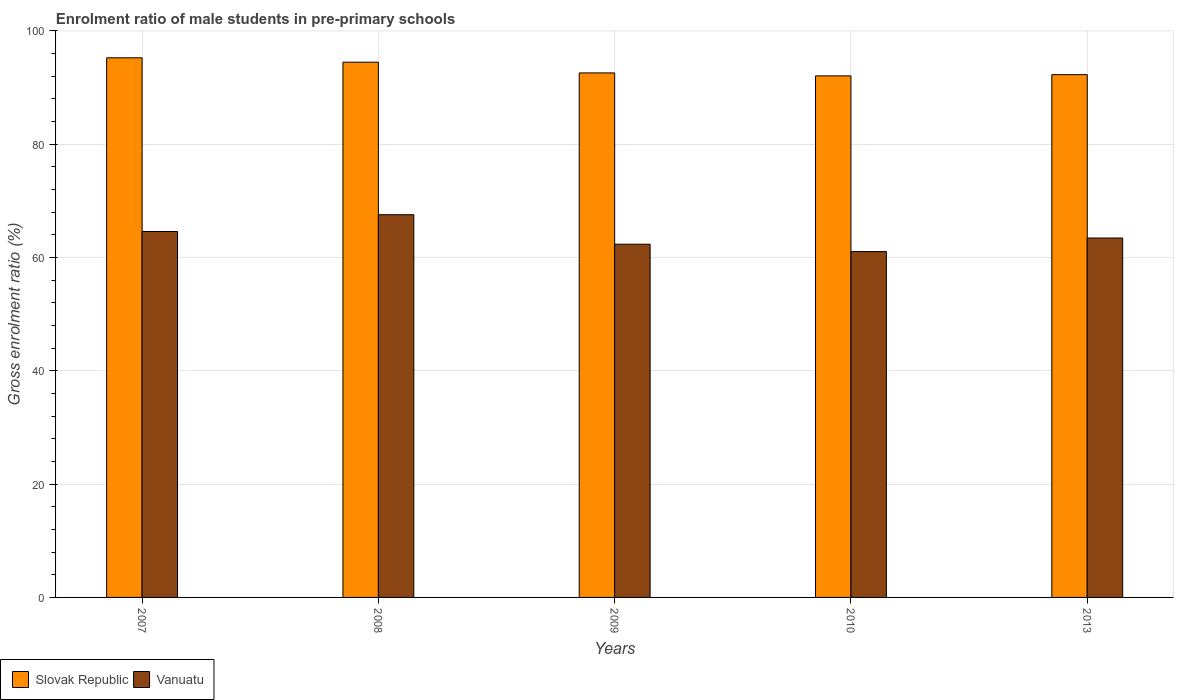How many different coloured bars are there?
Provide a succinct answer. 2. How many groups of bars are there?
Provide a succinct answer. 5. Are the number of bars per tick equal to the number of legend labels?
Ensure brevity in your answer.  Yes. How many bars are there on the 4th tick from the left?
Ensure brevity in your answer.  2. In how many cases, is the number of bars for a given year not equal to the number of legend labels?
Ensure brevity in your answer.  0. What is the enrolment ratio of male students in pre-primary schools in Slovak Republic in 2013?
Your response must be concise. 92.29. Across all years, what is the maximum enrolment ratio of male students in pre-primary schools in Vanuatu?
Your answer should be very brief. 67.56. Across all years, what is the minimum enrolment ratio of male students in pre-primary schools in Vanuatu?
Your answer should be compact. 61.05. In which year was the enrolment ratio of male students in pre-primary schools in Slovak Republic minimum?
Give a very brief answer. 2010. What is the total enrolment ratio of male students in pre-primary schools in Vanuatu in the graph?
Provide a succinct answer. 319.02. What is the difference between the enrolment ratio of male students in pre-primary schools in Vanuatu in 2010 and that in 2013?
Your answer should be compact. -2.39. What is the difference between the enrolment ratio of male students in pre-primary schools in Vanuatu in 2007 and the enrolment ratio of male students in pre-primary schools in Slovak Republic in 2009?
Ensure brevity in your answer.  -27.99. What is the average enrolment ratio of male students in pre-primary schools in Slovak Republic per year?
Offer a terse response. 93.34. In the year 2010, what is the difference between the enrolment ratio of male students in pre-primary schools in Vanuatu and enrolment ratio of male students in pre-primary schools in Slovak Republic?
Provide a succinct answer. -31.02. What is the ratio of the enrolment ratio of male students in pre-primary schools in Slovak Republic in 2007 to that in 2009?
Keep it short and to the point. 1.03. Is the difference between the enrolment ratio of male students in pre-primary schools in Vanuatu in 2009 and 2013 greater than the difference between the enrolment ratio of male students in pre-primary schools in Slovak Republic in 2009 and 2013?
Provide a short and direct response. No. What is the difference between the highest and the second highest enrolment ratio of male students in pre-primary schools in Slovak Republic?
Keep it short and to the point. 0.77. What is the difference between the highest and the lowest enrolment ratio of male students in pre-primary schools in Vanuatu?
Ensure brevity in your answer.  6.51. In how many years, is the enrolment ratio of male students in pre-primary schools in Vanuatu greater than the average enrolment ratio of male students in pre-primary schools in Vanuatu taken over all years?
Your answer should be compact. 2. What does the 1st bar from the left in 2009 represents?
Provide a succinct answer. Slovak Republic. What does the 1st bar from the right in 2009 represents?
Your answer should be very brief. Vanuatu. How many bars are there?
Provide a succinct answer. 10. How many years are there in the graph?
Offer a very short reply. 5. Does the graph contain any zero values?
Offer a very short reply. No. What is the title of the graph?
Give a very brief answer. Enrolment ratio of male students in pre-primary schools. What is the label or title of the X-axis?
Offer a very short reply. Years. What is the label or title of the Y-axis?
Ensure brevity in your answer.  Gross enrolment ratio (%). What is the Gross enrolment ratio (%) in Slovak Republic in 2007?
Offer a very short reply. 95.26. What is the Gross enrolment ratio (%) of Vanuatu in 2007?
Your answer should be compact. 64.6. What is the Gross enrolment ratio (%) in Slovak Republic in 2008?
Give a very brief answer. 94.49. What is the Gross enrolment ratio (%) of Vanuatu in 2008?
Your answer should be very brief. 67.56. What is the Gross enrolment ratio (%) of Slovak Republic in 2009?
Provide a short and direct response. 92.6. What is the Gross enrolment ratio (%) of Vanuatu in 2009?
Offer a terse response. 62.36. What is the Gross enrolment ratio (%) in Slovak Republic in 2010?
Ensure brevity in your answer.  92.07. What is the Gross enrolment ratio (%) of Vanuatu in 2010?
Ensure brevity in your answer.  61.05. What is the Gross enrolment ratio (%) in Slovak Republic in 2013?
Make the answer very short. 92.29. What is the Gross enrolment ratio (%) in Vanuatu in 2013?
Make the answer very short. 63.45. Across all years, what is the maximum Gross enrolment ratio (%) of Slovak Republic?
Your answer should be compact. 95.26. Across all years, what is the maximum Gross enrolment ratio (%) of Vanuatu?
Offer a terse response. 67.56. Across all years, what is the minimum Gross enrolment ratio (%) in Slovak Republic?
Your answer should be very brief. 92.07. Across all years, what is the minimum Gross enrolment ratio (%) in Vanuatu?
Offer a terse response. 61.05. What is the total Gross enrolment ratio (%) of Slovak Republic in the graph?
Provide a short and direct response. 466.71. What is the total Gross enrolment ratio (%) in Vanuatu in the graph?
Make the answer very short. 319.02. What is the difference between the Gross enrolment ratio (%) of Slovak Republic in 2007 and that in 2008?
Your response must be concise. 0.77. What is the difference between the Gross enrolment ratio (%) in Vanuatu in 2007 and that in 2008?
Offer a very short reply. -2.96. What is the difference between the Gross enrolment ratio (%) in Slovak Republic in 2007 and that in 2009?
Your answer should be compact. 2.67. What is the difference between the Gross enrolment ratio (%) in Vanuatu in 2007 and that in 2009?
Provide a succinct answer. 2.25. What is the difference between the Gross enrolment ratio (%) in Slovak Republic in 2007 and that in 2010?
Your answer should be compact. 3.19. What is the difference between the Gross enrolment ratio (%) in Vanuatu in 2007 and that in 2010?
Your response must be concise. 3.55. What is the difference between the Gross enrolment ratio (%) in Slovak Republic in 2007 and that in 2013?
Give a very brief answer. 2.97. What is the difference between the Gross enrolment ratio (%) of Vanuatu in 2007 and that in 2013?
Offer a terse response. 1.16. What is the difference between the Gross enrolment ratio (%) in Slovak Republic in 2008 and that in 2009?
Provide a short and direct response. 1.89. What is the difference between the Gross enrolment ratio (%) in Vanuatu in 2008 and that in 2009?
Offer a terse response. 5.21. What is the difference between the Gross enrolment ratio (%) of Slovak Republic in 2008 and that in 2010?
Your response must be concise. 2.42. What is the difference between the Gross enrolment ratio (%) of Vanuatu in 2008 and that in 2010?
Ensure brevity in your answer.  6.51. What is the difference between the Gross enrolment ratio (%) in Slovak Republic in 2008 and that in 2013?
Your answer should be very brief. 2.2. What is the difference between the Gross enrolment ratio (%) in Vanuatu in 2008 and that in 2013?
Provide a succinct answer. 4.12. What is the difference between the Gross enrolment ratio (%) in Slovak Republic in 2009 and that in 2010?
Your response must be concise. 0.52. What is the difference between the Gross enrolment ratio (%) in Vanuatu in 2009 and that in 2010?
Ensure brevity in your answer.  1.3. What is the difference between the Gross enrolment ratio (%) of Slovak Republic in 2009 and that in 2013?
Your answer should be compact. 0.3. What is the difference between the Gross enrolment ratio (%) of Vanuatu in 2009 and that in 2013?
Your answer should be compact. -1.09. What is the difference between the Gross enrolment ratio (%) in Slovak Republic in 2010 and that in 2013?
Make the answer very short. -0.22. What is the difference between the Gross enrolment ratio (%) of Vanuatu in 2010 and that in 2013?
Provide a short and direct response. -2.39. What is the difference between the Gross enrolment ratio (%) in Slovak Republic in 2007 and the Gross enrolment ratio (%) in Vanuatu in 2008?
Your response must be concise. 27.7. What is the difference between the Gross enrolment ratio (%) in Slovak Republic in 2007 and the Gross enrolment ratio (%) in Vanuatu in 2009?
Your answer should be compact. 32.91. What is the difference between the Gross enrolment ratio (%) in Slovak Republic in 2007 and the Gross enrolment ratio (%) in Vanuatu in 2010?
Give a very brief answer. 34.21. What is the difference between the Gross enrolment ratio (%) of Slovak Republic in 2007 and the Gross enrolment ratio (%) of Vanuatu in 2013?
Offer a very short reply. 31.82. What is the difference between the Gross enrolment ratio (%) of Slovak Republic in 2008 and the Gross enrolment ratio (%) of Vanuatu in 2009?
Make the answer very short. 32.13. What is the difference between the Gross enrolment ratio (%) in Slovak Republic in 2008 and the Gross enrolment ratio (%) in Vanuatu in 2010?
Provide a short and direct response. 33.44. What is the difference between the Gross enrolment ratio (%) in Slovak Republic in 2008 and the Gross enrolment ratio (%) in Vanuatu in 2013?
Keep it short and to the point. 31.04. What is the difference between the Gross enrolment ratio (%) of Slovak Republic in 2009 and the Gross enrolment ratio (%) of Vanuatu in 2010?
Your response must be concise. 31.54. What is the difference between the Gross enrolment ratio (%) of Slovak Republic in 2009 and the Gross enrolment ratio (%) of Vanuatu in 2013?
Provide a succinct answer. 29.15. What is the difference between the Gross enrolment ratio (%) of Slovak Republic in 2010 and the Gross enrolment ratio (%) of Vanuatu in 2013?
Your answer should be compact. 28.63. What is the average Gross enrolment ratio (%) of Slovak Republic per year?
Offer a very short reply. 93.34. What is the average Gross enrolment ratio (%) in Vanuatu per year?
Make the answer very short. 63.8. In the year 2007, what is the difference between the Gross enrolment ratio (%) in Slovak Republic and Gross enrolment ratio (%) in Vanuatu?
Your answer should be very brief. 30.66. In the year 2008, what is the difference between the Gross enrolment ratio (%) of Slovak Republic and Gross enrolment ratio (%) of Vanuatu?
Ensure brevity in your answer.  26.93. In the year 2009, what is the difference between the Gross enrolment ratio (%) in Slovak Republic and Gross enrolment ratio (%) in Vanuatu?
Keep it short and to the point. 30.24. In the year 2010, what is the difference between the Gross enrolment ratio (%) of Slovak Republic and Gross enrolment ratio (%) of Vanuatu?
Your answer should be compact. 31.02. In the year 2013, what is the difference between the Gross enrolment ratio (%) in Slovak Republic and Gross enrolment ratio (%) in Vanuatu?
Your response must be concise. 28.84. What is the ratio of the Gross enrolment ratio (%) in Slovak Republic in 2007 to that in 2008?
Your response must be concise. 1.01. What is the ratio of the Gross enrolment ratio (%) of Vanuatu in 2007 to that in 2008?
Your response must be concise. 0.96. What is the ratio of the Gross enrolment ratio (%) in Slovak Republic in 2007 to that in 2009?
Offer a very short reply. 1.03. What is the ratio of the Gross enrolment ratio (%) of Vanuatu in 2007 to that in 2009?
Provide a short and direct response. 1.04. What is the ratio of the Gross enrolment ratio (%) in Slovak Republic in 2007 to that in 2010?
Keep it short and to the point. 1.03. What is the ratio of the Gross enrolment ratio (%) of Vanuatu in 2007 to that in 2010?
Keep it short and to the point. 1.06. What is the ratio of the Gross enrolment ratio (%) of Slovak Republic in 2007 to that in 2013?
Ensure brevity in your answer.  1.03. What is the ratio of the Gross enrolment ratio (%) of Vanuatu in 2007 to that in 2013?
Offer a very short reply. 1.02. What is the ratio of the Gross enrolment ratio (%) in Slovak Republic in 2008 to that in 2009?
Provide a succinct answer. 1.02. What is the ratio of the Gross enrolment ratio (%) in Vanuatu in 2008 to that in 2009?
Your response must be concise. 1.08. What is the ratio of the Gross enrolment ratio (%) of Slovak Republic in 2008 to that in 2010?
Give a very brief answer. 1.03. What is the ratio of the Gross enrolment ratio (%) in Vanuatu in 2008 to that in 2010?
Your answer should be very brief. 1.11. What is the ratio of the Gross enrolment ratio (%) in Slovak Republic in 2008 to that in 2013?
Keep it short and to the point. 1.02. What is the ratio of the Gross enrolment ratio (%) in Vanuatu in 2008 to that in 2013?
Give a very brief answer. 1.06. What is the ratio of the Gross enrolment ratio (%) in Vanuatu in 2009 to that in 2010?
Your answer should be very brief. 1.02. What is the ratio of the Gross enrolment ratio (%) in Slovak Republic in 2009 to that in 2013?
Make the answer very short. 1. What is the ratio of the Gross enrolment ratio (%) of Vanuatu in 2009 to that in 2013?
Keep it short and to the point. 0.98. What is the ratio of the Gross enrolment ratio (%) of Slovak Republic in 2010 to that in 2013?
Your response must be concise. 1. What is the ratio of the Gross enrolment ratio (%) of Vanuatu in 2010 to that in 2013?
Your answer should be very brief. 0.96. What is the difference between the highest and the second highest Gross enrolment ratio (%) in Slovak Republic?
Offer a very short reply. 0.77. What is the difference between the highest and the second highest Gross enrolment ratio (%) in Vanuatu?
Give a very brief answer. 2.96. What is the difference between the highest and the lowest Gross enrolment ratio (%) in Slovak Republic?
Make the answer very short. 3.19. What is the difference between the highest and the lowest Gross enrolment ratio (%) in Vanuatu?
Your response must be concise. 6.51. 